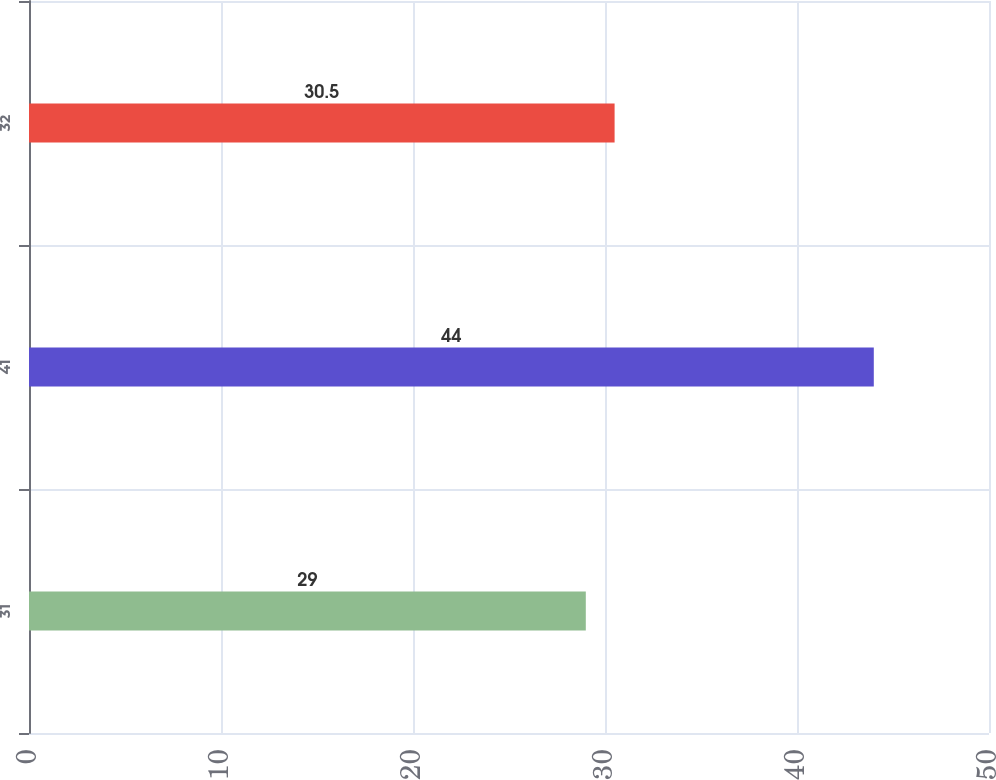Convert chart to OTSL. <chart><loc_0><loc_0><loc_500><loc_500><bar_chart><fcel>31<fcel>41<fcel>32<nl><fcel>29<fcel>44<fcel>30.5<nl></chart> 